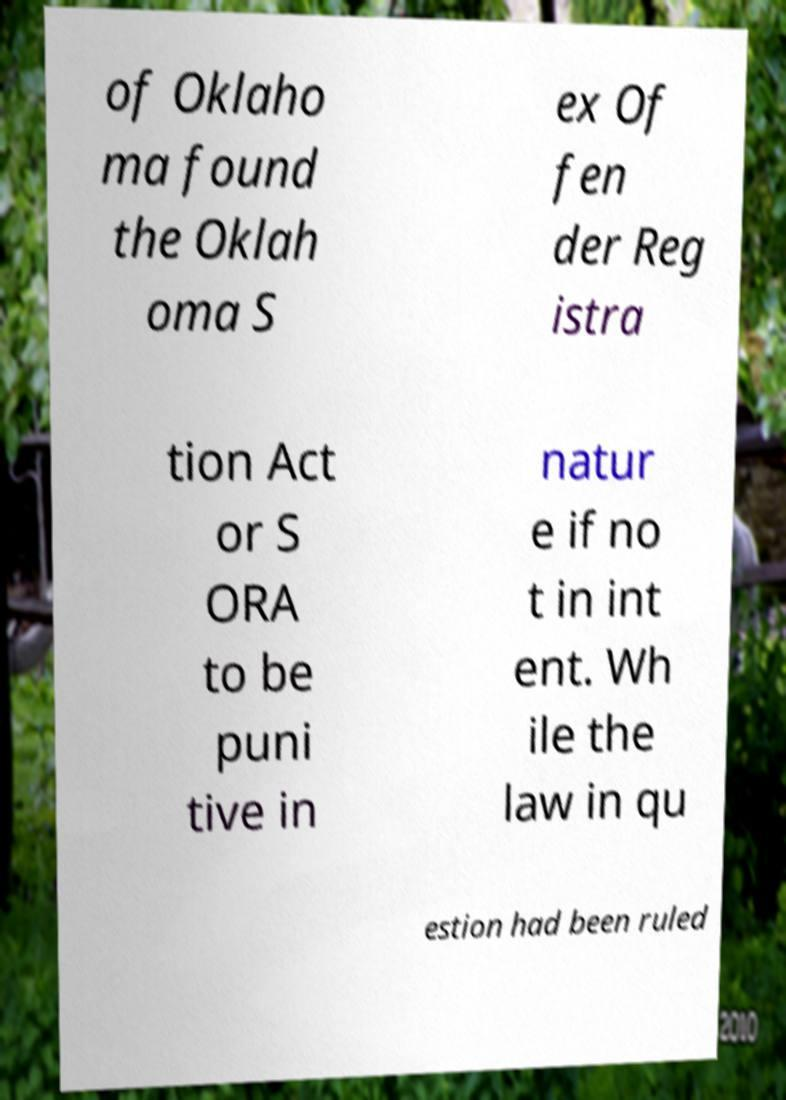For documentation purposes, I need the text within this image transcribed. Could you provide that? of Oklaho ma found the Oklah oma S ex Of fen der Reg istra tion Act or S ORA to be puni tive in natur e if no t in int ent. Wh ile the law in qu estion had been ruled 